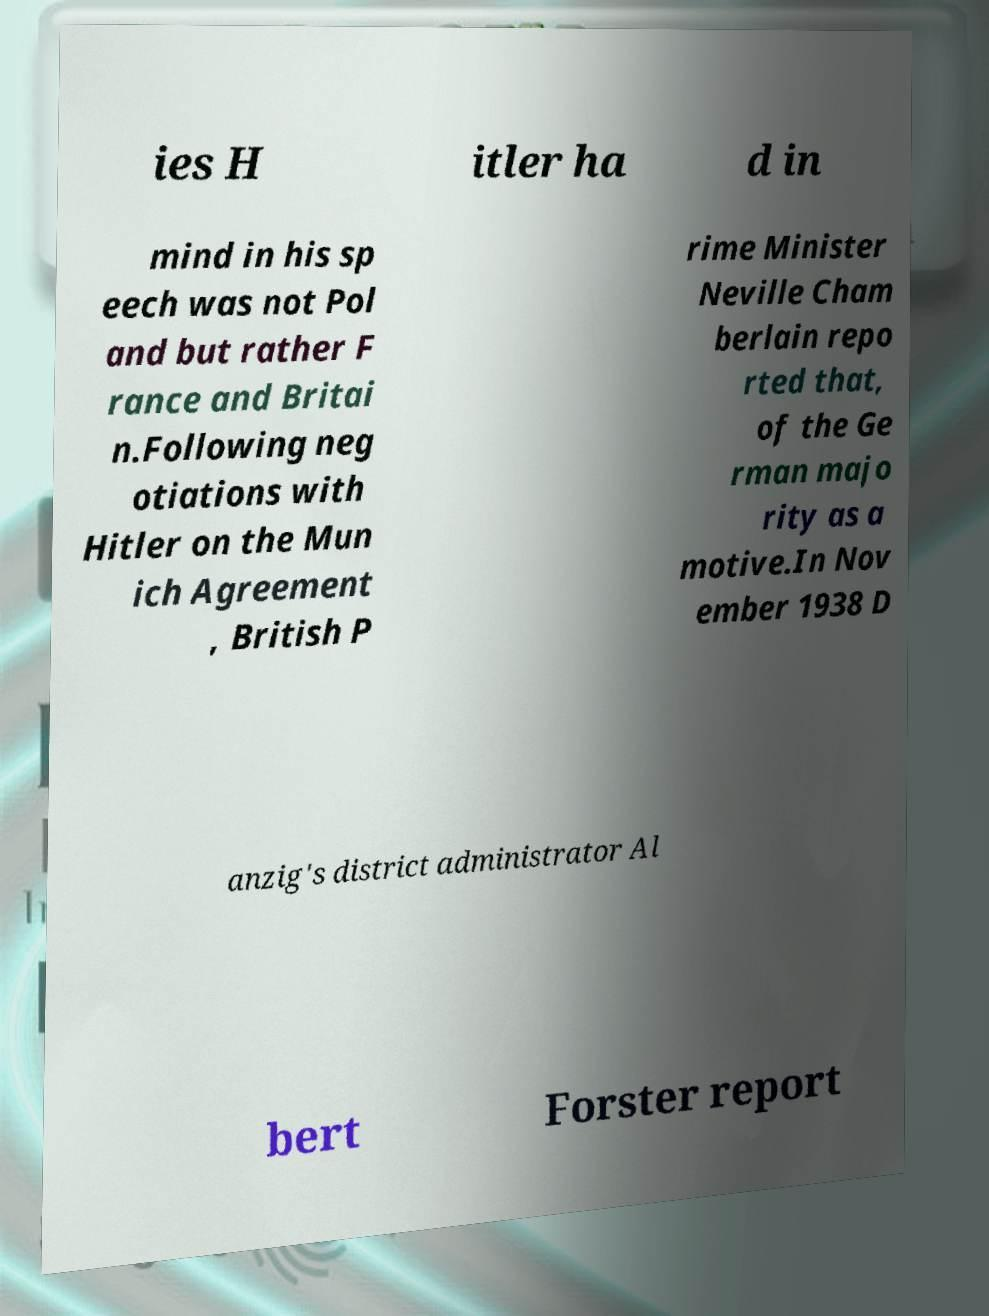I need the written content from this picture converted into text. Can you do that? ies H itler ha d in mind in his sp eech was not Pol and but rather F rance and Britai n.Following neg otiations with Hitler on the Mun ich Agreement , British P rime Minister Neville Cham berlain repo rted that, of the Ge rman majo rity as a motive.In Nov ember 1938 D anzig's district administrator Al bert Forster report 